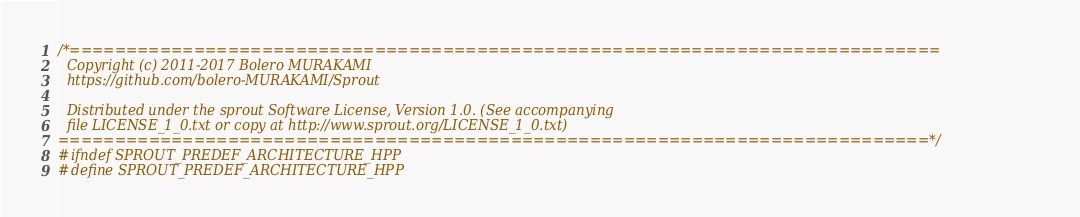<code> <loc_0><loc_0><loc_500><loc_500><_C++_>/*=============================================================================
  Copyright (c) 2011-2017 Bolero MURAKAMI
  https://github.com/bolero-MURAKAMI/Sprout

  Distributed under the sprout Software License, Version 1.0. (See accompanying
  file LICENSE_1_0.txt or copy at http://www.sprout.org/LICENSE_1_0.txt)
=============================================================================*/
#ifndef SPROUT_PREDEF_ARCHITECTURE_HPP
#define SPROUT_PREDEF_ARCHITECTURE_HPP
</code> 